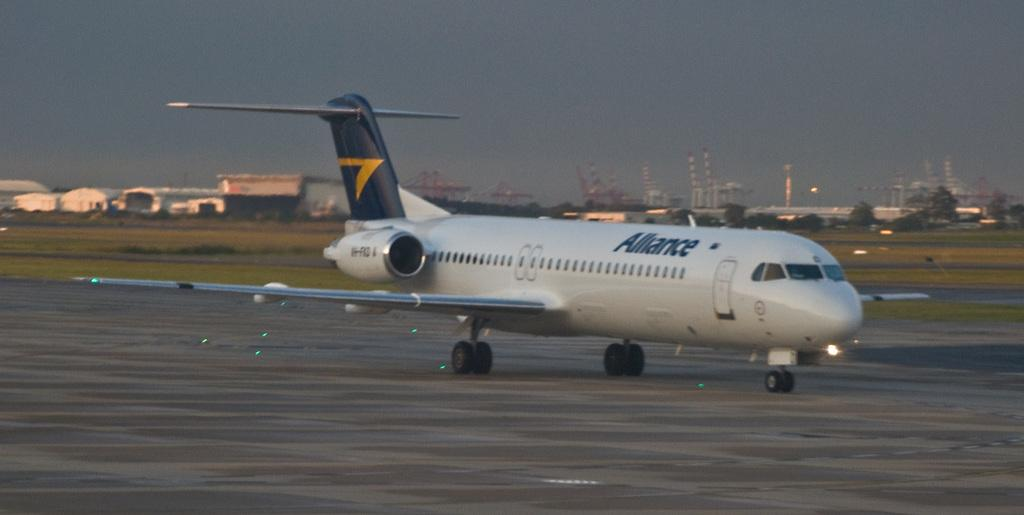<image>
Share a concise interpretation of the image provided. Long airplane with the word ALLIANCE on it is getting ready for take off. 